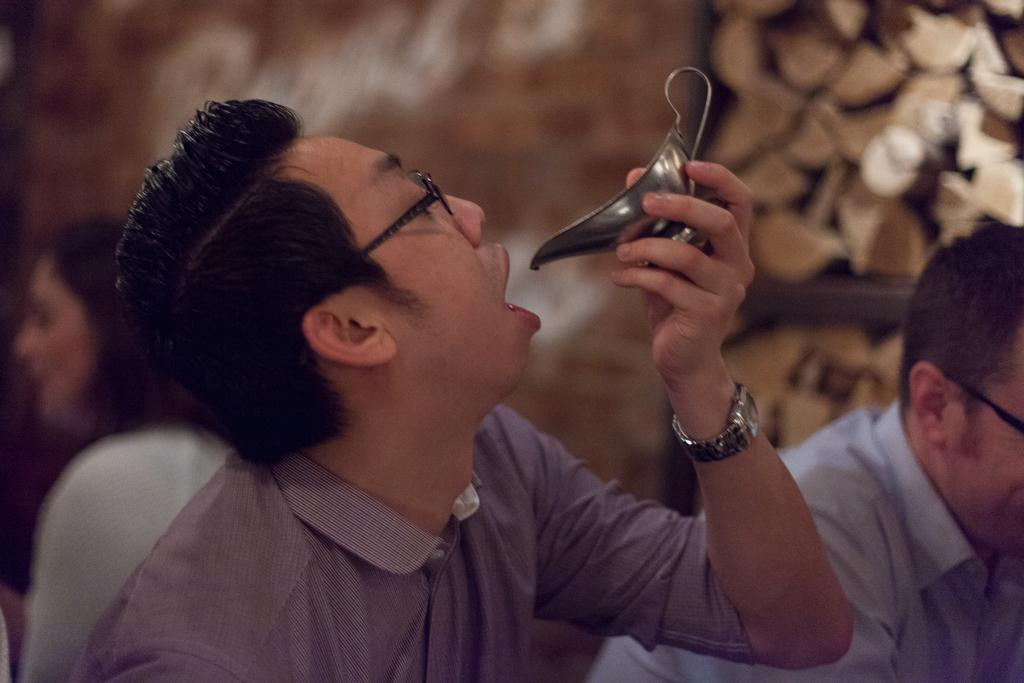What can be seen in the image? There is a person in the image. What is the person wearing? The person is wearing a watch and a shirt. What is the person holding in his hand? The person is holding a utensil in his hand. Are there any other people visible in the image? Yes, there are other persons visible in the background of the image. How would you describe the background of the image? The background of the image is blurry. What type of ring is the person wearing on their finger in the image? There is no ring visible on the person's finger in the image. 